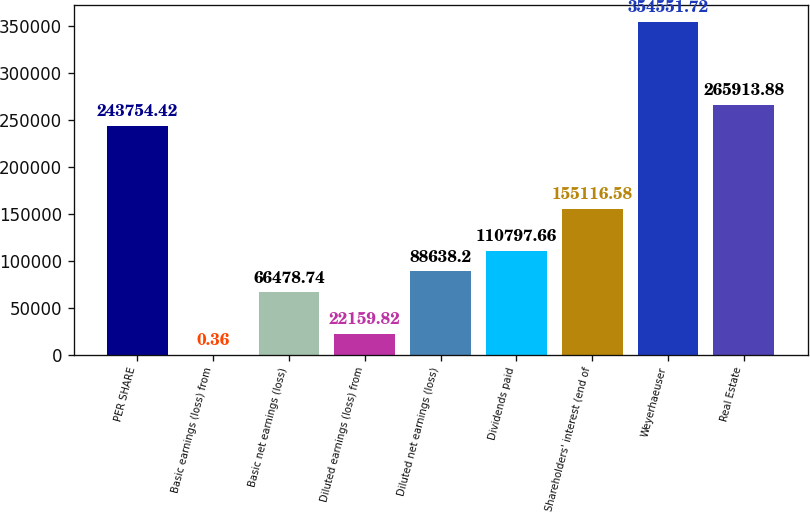<chart> <loc_0><loc_0><loc_500><loc_500><bar_chart><fcel>PER SHARE<fcel>Basic earnings (loss) from<fcel>Basic net earnings (loss)<fcel>Diluted earnings (loss) from<fcel>Diluted net earnings (loss)<fcel>Dividends paid<fcel>Shareholders' interest (end of<fcel>Weyerhaeuser<fcel>Real Estate<nl><fcel>243754<fcel>0.36<fcel>66478.7<fcel>22159.8<fcel>88638.2<fcel>110798<fcel>155117<fcel>354552<fcel>265914<nl></chart> 